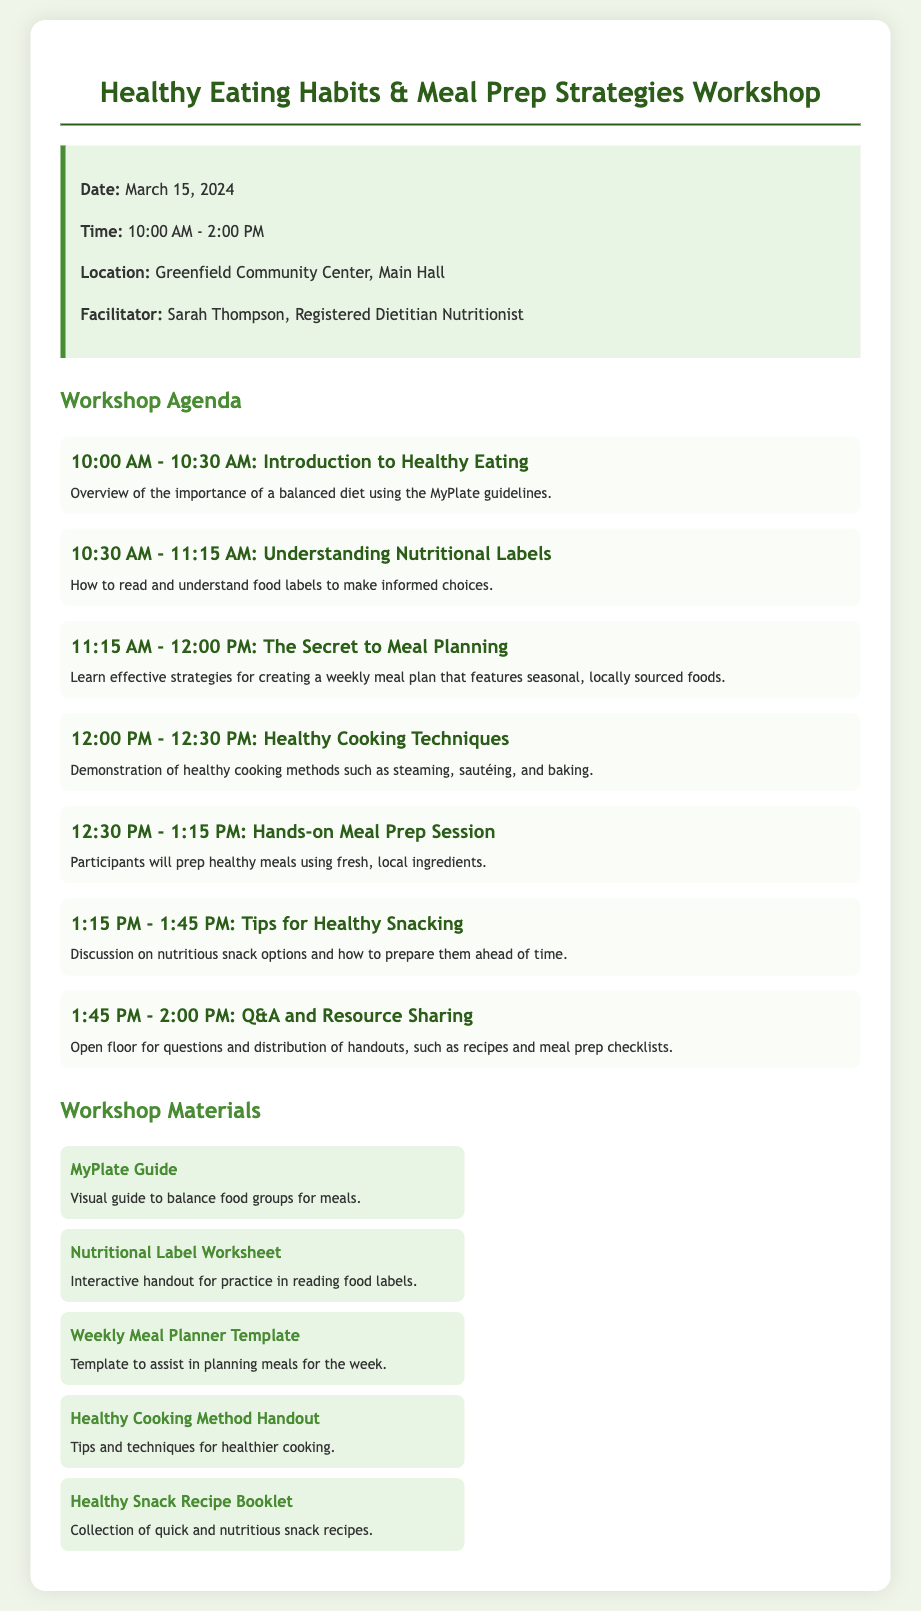What is the date of the workshop? The date of the workshop is clearly stated in the document, which is March 15, 2024.
Answer: March 15, 2024 Who is the facilitator of the workshop? The document specifies that the facilitator of the workshop is Sarah Thompson, Registered Dietitian Nutritionist.
Answer: Sarah Thompson What time does the workshop start? The agenda indicates that the workshop starts at 10:00 AM.
Answer: 10:00 AM What topic is covered from 11:15 AM to 12:00 PM? The agenda lists "The Secret to Meal Planning" as the topic for that time slot.
Answer: The Secret to Meal Planning How long is the Q&A session at the end of the workshop? According to the agenda, the Q&A session lasts for 15 minutes, from 1:45 PM to 2:00 PM.
Answer: 15 minutes What is one of the materials provided in the workshop? The document includes several materials, one of which is the "MyPlate Guide."
Answer: MyPlate Guide What is the focus of the hands-on meal prep session? The schedule indicates that participants will prep healthy meals using fresh, local ingredients.
Answer: Fresh, local ingredients What method of cooking will be demonstrated during the workshop? The agenda mentions healthy cooking methods such as steaming, sautéing, and baking will be demonstrated.
Answer: Steaming, sautéing, and baking What is the overall goal of the workshop? The workshop aims to teach healthy eating habits and meal prep strategies to clients, as stated in the title.
Answer: Healthy eating habits and meal prep strategies 